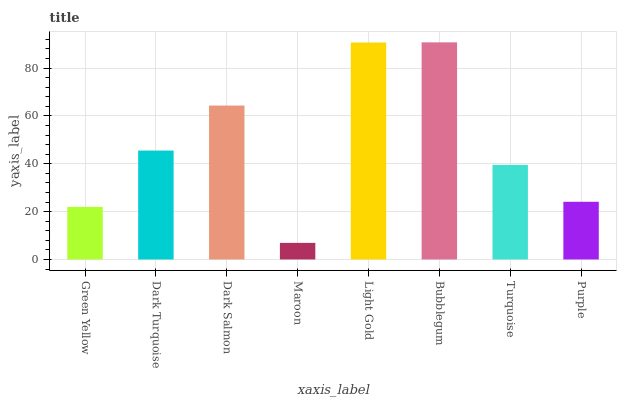Is Maroon the minimum?
Answer yes or no. Yes. Is Bubblegum the maximum?
Answer yes or no. Yes. Is Dark Turquoise the minimum?
Answer yes or no. No. Is Dark Turquoise the maximum?
Answer yes or no. No. Is Dark Turquoise greater than Green Yellow?
Answer yes or no. Yes. Is Green Yellow less than Dark Turquoise?
Answer yes or no. Yes. Is Green Yellow greater than Dark Turquoise?
Answer yes or no. No. Is Dark Turquoise less than Green Yellow?
Answer yes or no. No. Is Dark Turquoise the high median?
Answer yes or no. Yes. Is Turquoise the low median?
Answer yes or no. Yes. Is Turquoise the high median?
Answer yes or no. No. Is Bubblegum the low median?
Answer yes or no. No. 